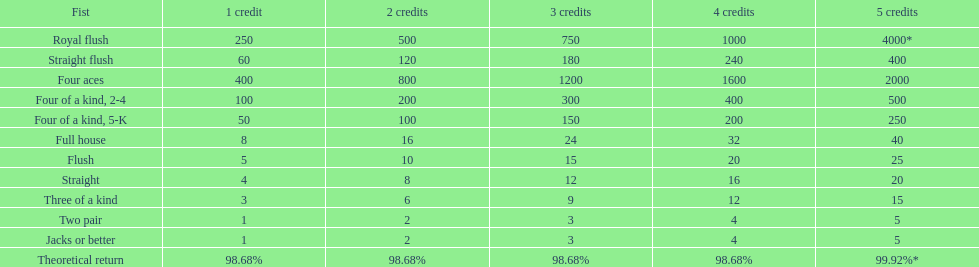The number of flush wins at one credit to equal one flush win at 5 credits. 5. 